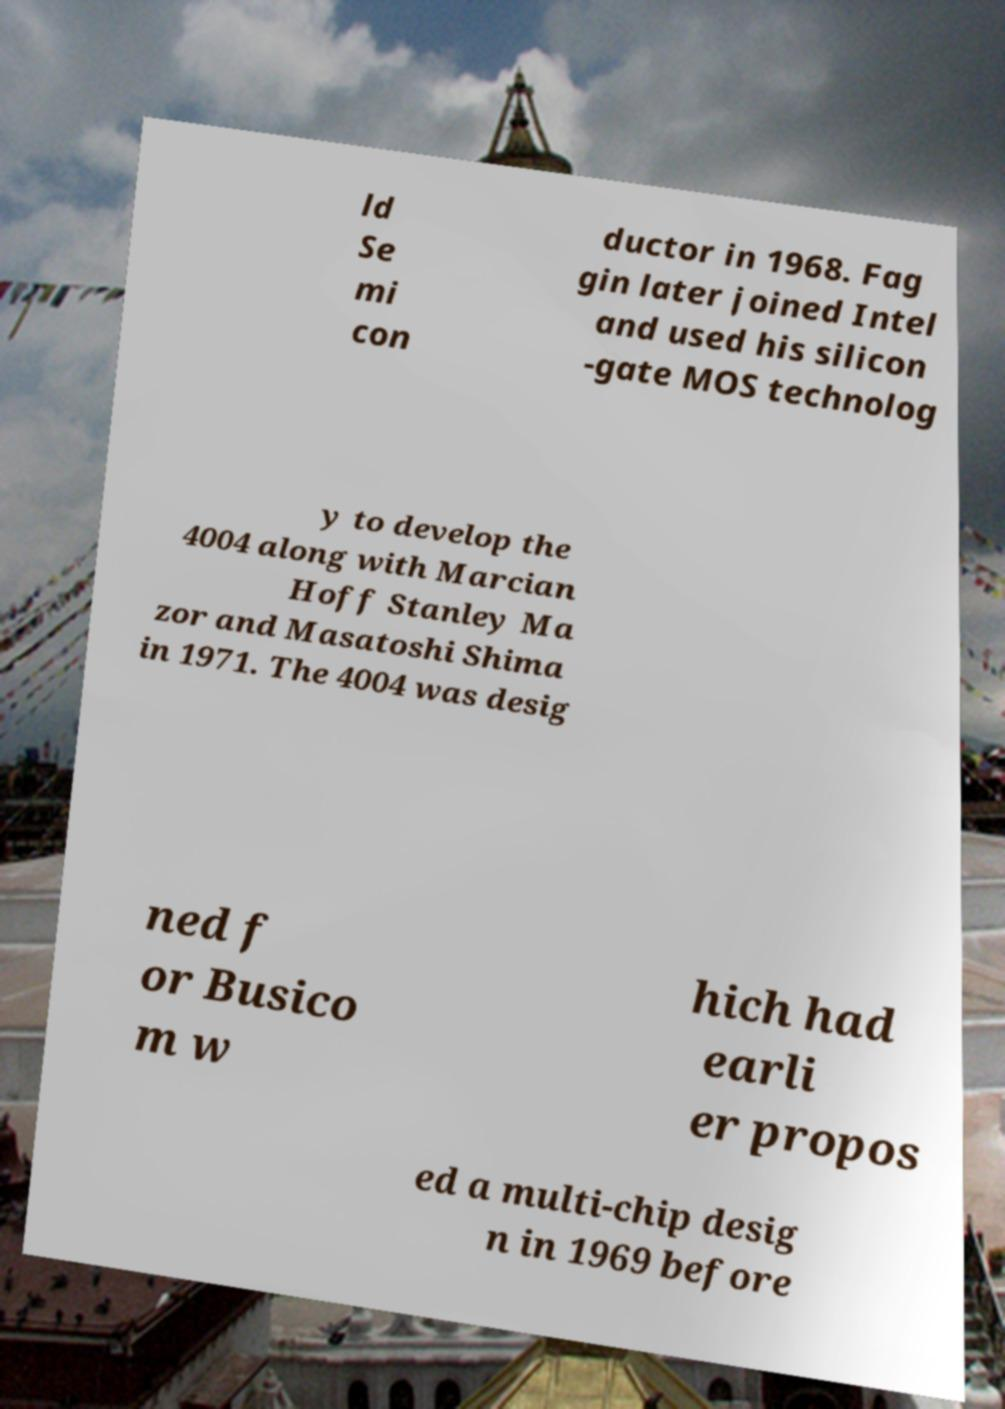There's text embedded in this image that I need extracted. Can you transcribe it verbatim? ld Se mi con ductor in 1968. Fag gin later joined Intel and used his silicon -gate MOS technolog y to develop the 4004 along with Marcian Hoff Stanley Ma zor and Masatoshi Shima in 1971. The 4004 was desig ned f or Busico m w hich had earli er propos ed a multi-chip desig n in 1969 before 